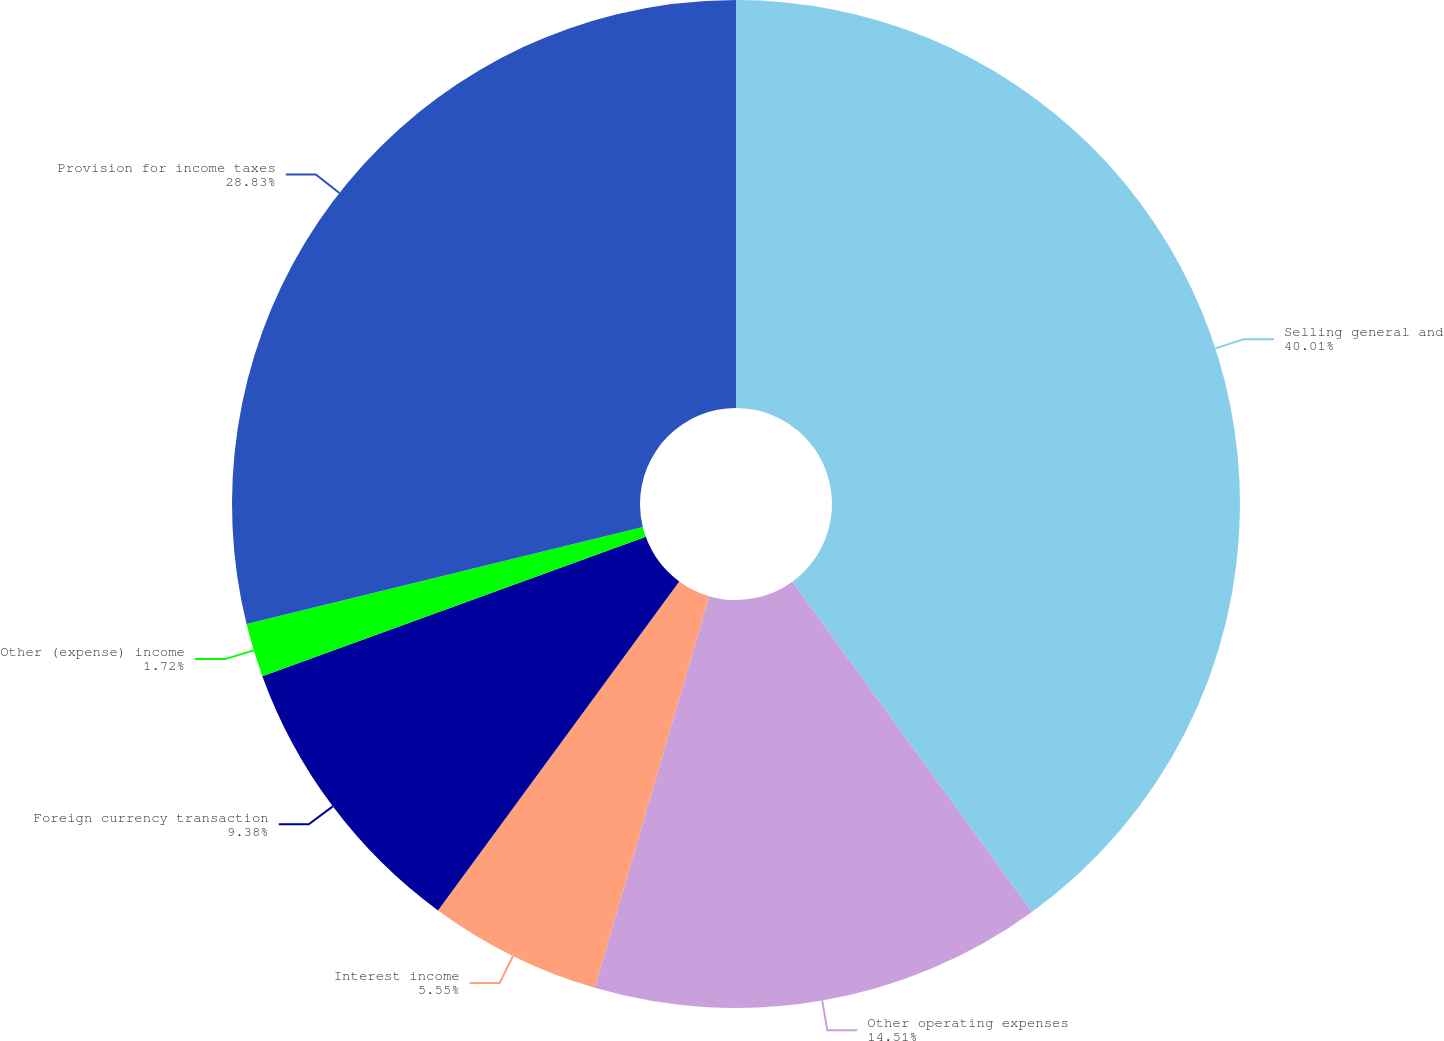<chart> <loc_0><loc_0><loc_500><loc_500><pie_chart><fcel>Selling general and<fcel>Other operating expenses<fcel>Interest income<fcel>Foreign currency transaction<fcel>Other (expense) income<fcel>Provision for income taxes<nl><fcel>40.01%<fcel>14.51%<fcel>5.55%<fcel>9.38%<fcel>1.72%<fcel>28.83%<nl></chart> 